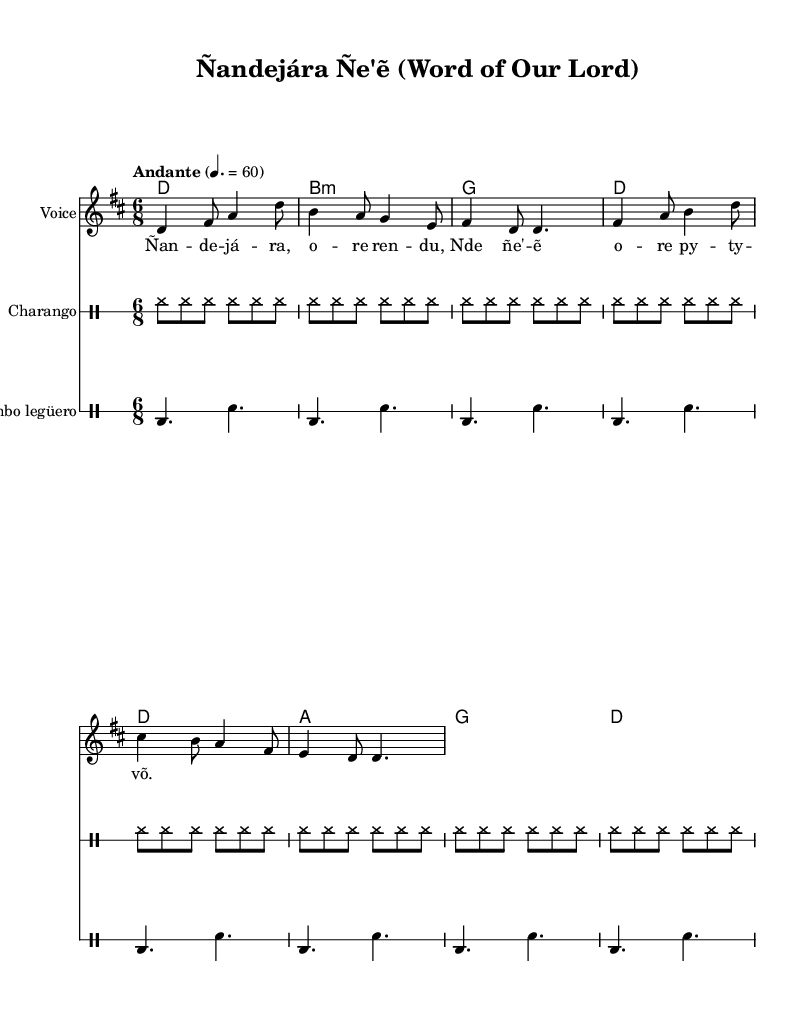What is the key signature of this piece? The key signature indicated in the sheet music is D major, which has two sharps: F# and C#.
Answer: D major What is the time signature of the music? The time signature shown in the sheet music is 6/8, which indicates there are six eighth notes per measure.
Answer: 6/8 What is the tempo marking for this piece? The tempo marking in the music states "Andante" with a metronome marking of 60, suggesting a moderately slow tempo.
Answer: Andante How many measures are there in the melody? Counting the measures in the melody line shown in the sheet music, there are a total of eight measures.
Answer: Eight What are the chords indicated for charango? The chords for charango given in the sheet music are D, B minor, G, and A, which support the harmonic structure of the melody.
Answer: D, B minor, G, A What is the significance of Guaraní themes in the lyrics? The lyrics integrate Guaraní language elements, emphasizing cultural identity and expressing religious devotion, blending indigenous and Christian themes.
Answer: Cultural identity What drum patterns are used in this piece? The drum parts consist of a charango rhythm and bombo legüero pattern, both providing a distinct musical texture typical of folk traditions.
Answer: Charango and bombo legüero 